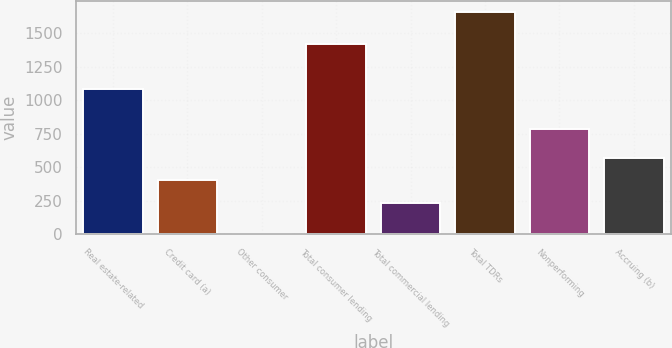<chart> <loc_0><loc_0><loc_500><loc_500><bar_chart><fcel>Real estate-related<fcel>Credit card (a)<fcel>Other consumer<fcel>Total consumer lending<fcel>Total commercial lending<fcel>Total TDRs<fcel>Nonperforming<fcel>Accruing (b)<nl><fcel>1087<fcel>401.4<fcel>4<fcel>1422<fcel>236<fcel>1658<fcel>784<fcel>566.8<nl></chart> 